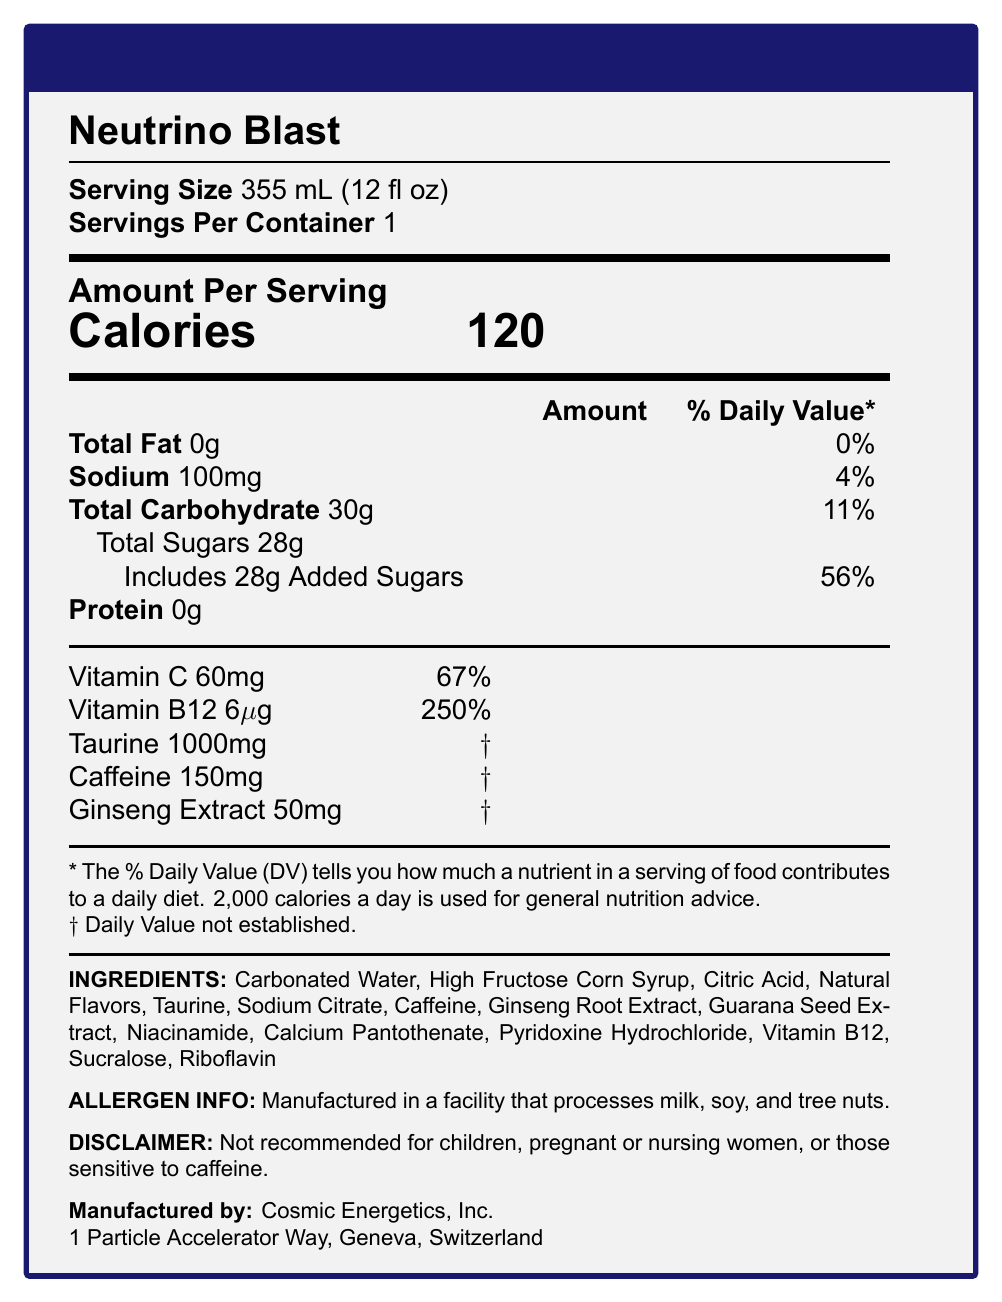what is the serving size? The serving size is clearly stated as 355 mL (12 fl oz) in the document.
Answer: 355 mL (12 fl oz) how many calories are in a serving of Neutrino Blast? The document lists 120 calories per serving.
Answer: 120 what is the daily value percentage for Vitamin C? The document specifies that 60mg of Vitamin C is 67% of the daily value.
Answer: 67% how much Taurine is included in the drink? The document states that there are 1000mg of Taurine in the drink.
Answer: 1000mg what is the recommended daily intake percentage for added sugars in Neutrino Blast? The document indicates that the drink contains 28g of added sugars, which is 56% of the daily value.
Answer: 56% which ingredient appears first on the list? Ingredients are listed in descending order by weight, and Carbonated Water is the first ingredient.
Answer: Carbonated Water how much Sodium does the drink contain? The drink contains 100mg of Sodium, as stated in the document.
Answer: 100mg what percentage of the daily value of Sodium does the drink provide? The document states that 100mg of Sodium is 4% of the daily value.
Answer: 4% which company manufactures Neutrino Blast? A. Cosmic Energetics, Inc. B. Stellar Drinks, Ltd. C. Nebula Beverages Co. D. Galactic Energy Corp. The document lists the manufacturer of Neutrino Blast as Cosmic Energetics, Inc.
Answer: A. Cosmic Energetics, Inc. which of the following vitamins is NOT listed as an ingredient? (A) Vitamin C, (B) Vitamin B12, (C) Vitamin D, (D) Riboflavin The document lists Vitamin C, Vitamin B12, and Riboflavin as ingredients, but not Vitamin D.
Answer: C. Vitamin D is Neutrino Blast recommended for children or pregnant women? The document has a disclaimer stating that the product is not recommended for children, pregnant or nursing women, or those sensitive to caffeine.
Answer: No summarize the main nutritional aspects of Neutrino Blast. This provides an overview of the drink's nutritional content and the main cautionary information included in the document.
Answer: Neutrino Blast is a high-energy drink with 120 calories per serving, zero fat, 100mg of sodium (4% DV), 30g of carbohydrates (11% DV), including 28g of added sugars (56% DV). It provides significant amounts of Vitamin C (67% DV) and Vitamin B12 (250% DV), along with 1000mg of Taurine and 150mg of caffeine. It also includes Ginseng Extract, among other ingredients. The drink is not recommended for children, pregnant or nursing women, or those sensitive to caffeine. is the amount of Riboflavin specified? While Riboflavin is listed as an ingredient, its quantity is not specified in the document.
Answer: No 